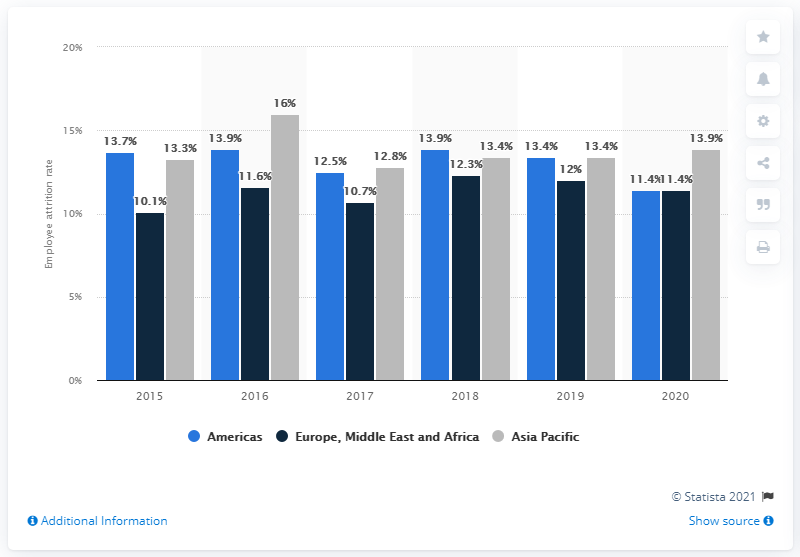Specify some key components in this picture. In 2020, the average employee attrition rate in the Americas was 11.4%. The average rate of employee attrition in the Asia Pacific region between 2013 and 2020 was 13.9%. The difference between the highest and lowest dark blue bar is 2.2. The value of the highest dark blue bar is 12.3. 